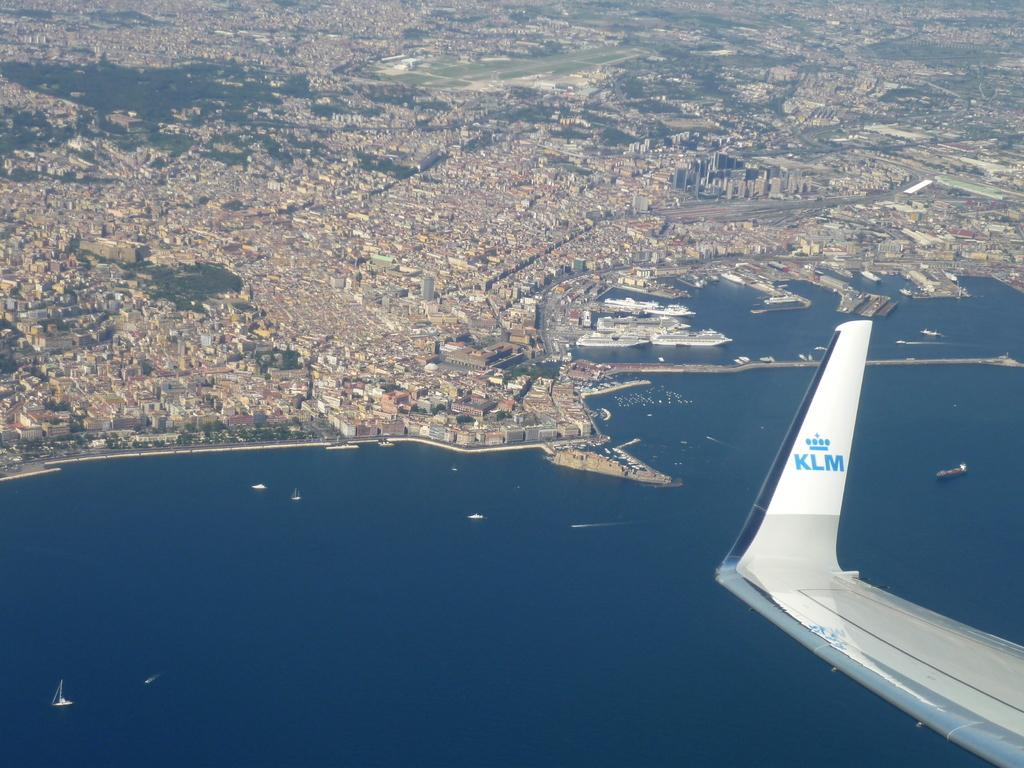Provide a one-sentence caption for the provided image. The wing of an airplane with the KLM logo can be seen above water and land. 